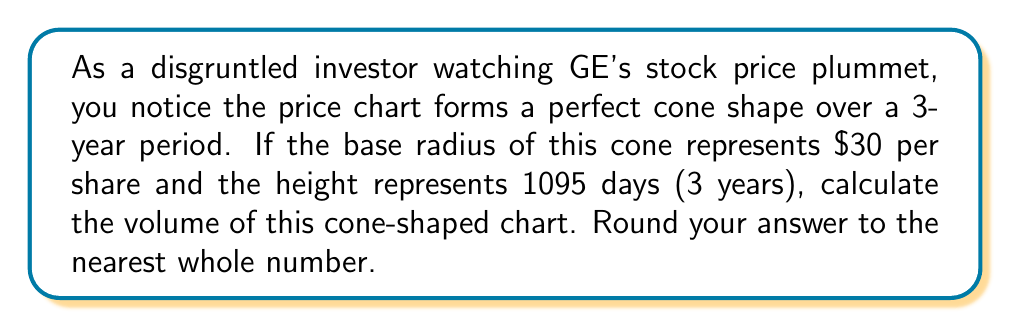Could you help me with this problem? To solve this problem, we'll use the formula for the volume of a cone:

$$V = \frac{1}{3}\pi r^2 h$$

Where:
$V$ = volume
$r$ = radius of the base
$h$ = height of the cone

Given:
- Base radius ($r$) = $30 (representing $30 per share)
- Height ($h$) = 1095 days

Step 1: Substitute the values into the formula
$$V = \frac{1}{3}\pi (30)^2 (1095)$$

Step 2: Calculate the squared radius
$$V = \frac{1}{3}\pi (900) (1095)$$

Step 3: Multiply the numbers
$$V = \frac{1}{3}\pi (985500)$$

Step 4: Calculate the result
$$V = 328500\pi$$

Step 5: Evaluate and round to the nearest whole number
$$V \approx 1031868$$

[asy]
import three;

size(200);
currentprojection=perspective(6,3,2);

triple A = (0,0,0), B = (3,0,0), C = (0,3,0), O = (0,0,10);

draw(O--A--B--cycle);
draw(O--C);

label("1095 days", O--A, W);
label("$30", A--B, S);

draw(arc(A,1,90,0,180), dashed);
[/asy]
Answer: The volume of the cone-shaped stock price chart is approximately 1,031,868 cubic units. 